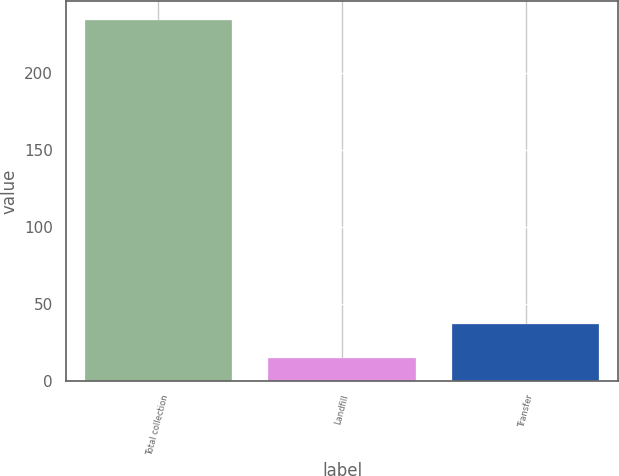Convert chart. <chart><loc_0><loc_0><loc_500><loc_500><bar_chart><fcel>Total collection<fcel>Landfill<fcel>Transfer<nl><fcel>235<fcel>15<fcel>37<nl></chart> 